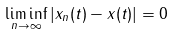Convert formula to latex. <formula><loc_0><loc_0><loc_500><loc_500>\liminf _ { n \to \infty } | x _ { n } ( t ) - x ( t ) | = 0</formula> 